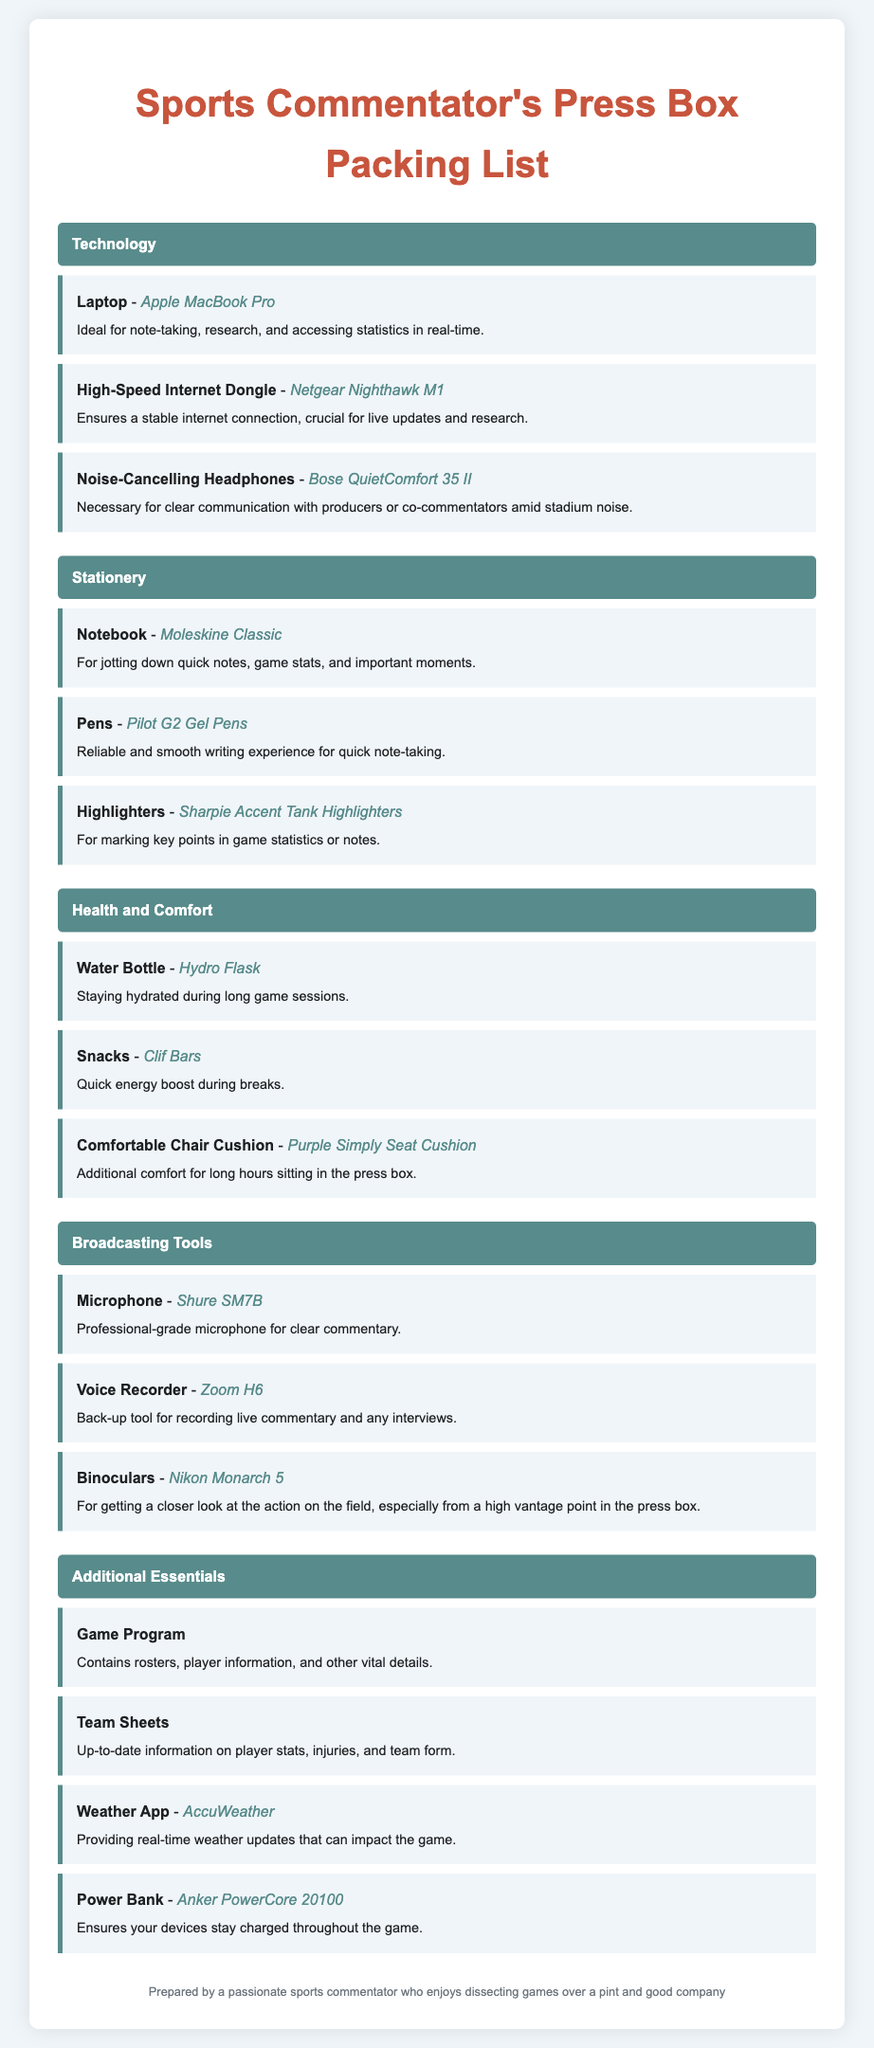What is the ideal laptop for a sports commentator? The document lists the Apple MacBook Pro as the ideal laptop for a sports commentator.
Answer: Apple MacBook Pro What type of headphones should a sports commentator use? According to the document, Noise-Cancelling Headphones are recommended, specifically the Bose QuietComfort 35 II.
Answer: Bose QuietComfort 35 II How many types of stationery items are listed? The document mentions three types of stationery items: Notebook, Pens, and Highlighters.
Answer: Three What is one item listed under Health and Comfort? The document includes a Water Bottle as an item under Health and Comfort.
Answer: Water Bottle What broadcasting tool is recommended for clear commentary? The Shure SM7B is noted in the document as a professional-grade microphone for clear commentary.
Answer: Shure SM7B Which brand of highlighters is suggested? The document suggests using Sharpie Accent Tank Highlighters.
Answer: Sharpie Accent Tank Highlighters Why is a Power Bank important for a sports commentator? A Power Bank is essential to ensure devices remain charged throughout the game, as indicated in the document.
Answer: To ensure devices stay charged What is included in the Additional Essentials category? The items include Game Program, Team Sheets, Weather App, and Power Bank.
Answer: Game Program, Team Sheets, Weather App, Power Bank What brand of snacks is mentioned for quick energy? Clif Bars are the brand of snacks recommended for a quick energy boost during breaks.
Answer: Clif Bars 